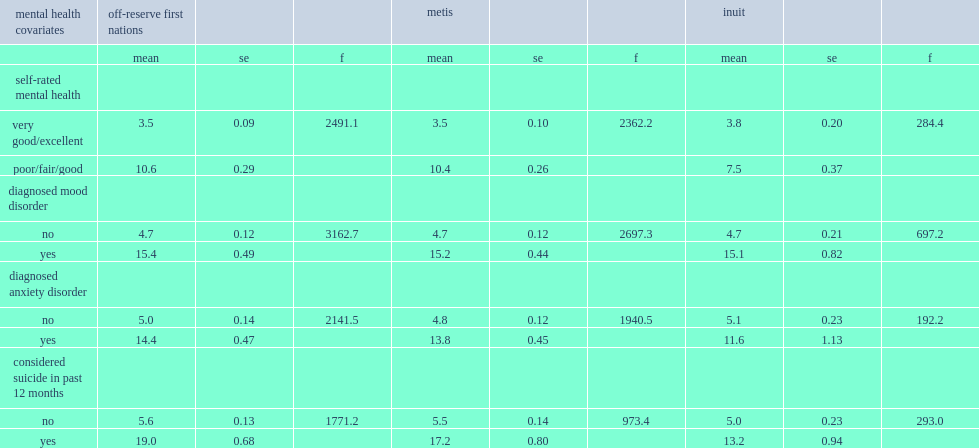First nations people living off reserve, metis, and inuit, which type of people had significantly higher distress scores, who reported poor/fair/good mental health or those who reported very good/excellent mental health? Poor/fair/good. 